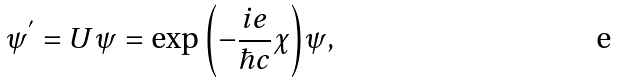Convert formula to latex. <formula><loc_0><loc_0><loc_500><loc_500>\psi ^ { ^ { \prime } } = U \psi = \exp { \left ( - \frac { i e } { \hbar { c } } \chi \right ) } \psi ,</formula> 